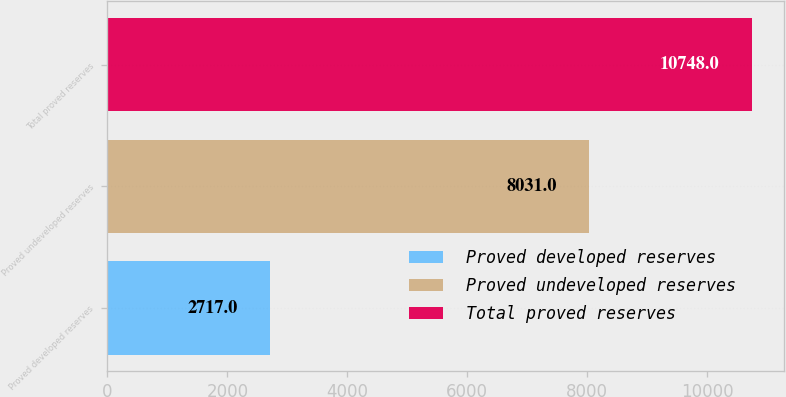Convert chart. <chart><loc_0><loc_0><loc_500><loc_500><bar_chart><fcel>Proved developed reserves<fcel>Proved undeveloped reserves<fcel>Total proved reserves<nl><fcel>2717<fcel>8031<fcel>10748<nl></chart> 